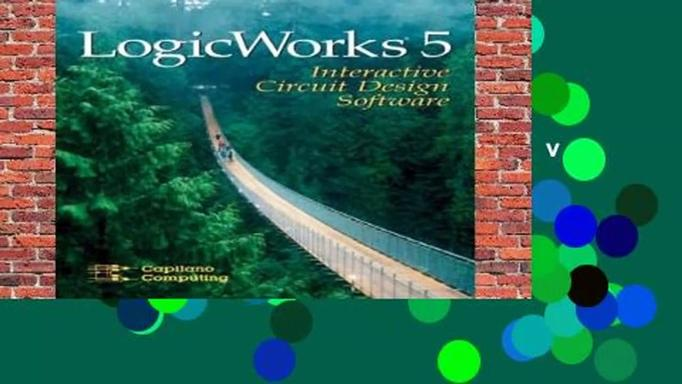What are the main features of LogicWorks 5 software? LogicWorks 5 boasts several key features including an intuitive user interface, a comprehensive digital component library, real-time simulation capabilities, and tools for creating and testing various digital circuit designs. It also offers educational resources that are particularly helpful for students and newcomers in digital electronics. 